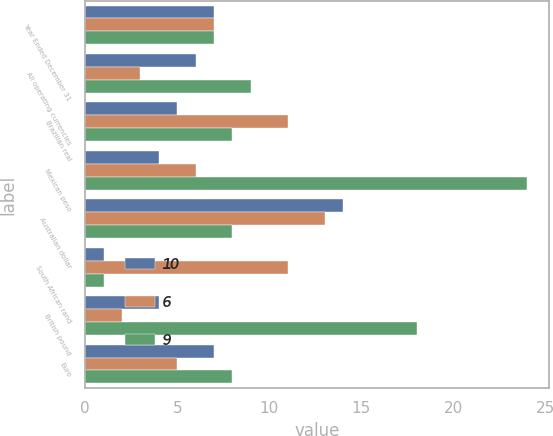Convert chart. <chart><loc_0><loc_0><loc_500><loc_500><stacked_bar_chart><ecel><fcel>Year Ended December 31<fcel>All operating currencies<fcel>Brazilian real<fcel>Mexican peso<fcel>Australian dollar<fcel>South African rand<fcel>British pound<fcel>Euro<nl><fcel>10<fcel>7<fcel>6<fcel>5<fcel>4<fcel>14<fcel>1<fcel>4<fcel>7<nl><fcel>6<fcel>7<fcel>3<fcel>11<fcel>6<fcel>13<fcel>11<fcel>2<fcel>5<nl><fcel>9<fcel>7<fcel>9<fcel>8<fcel>24<fcel>8<fcel>1<fcel>18<fcel>8<nl></chart> 